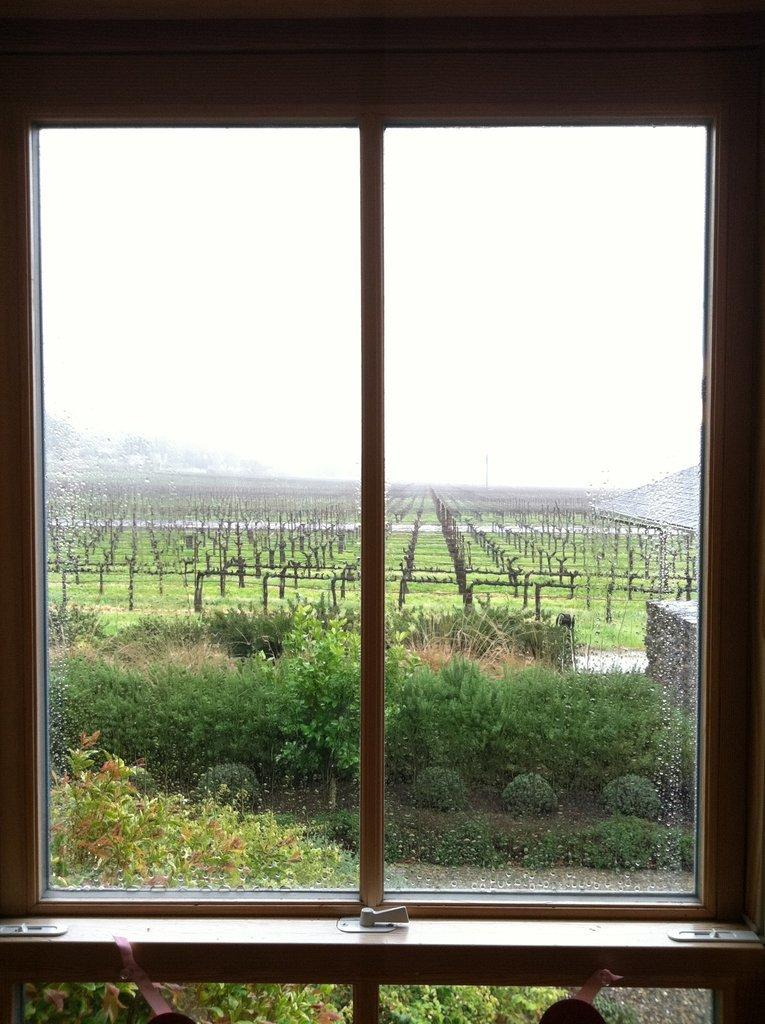What is the main object visible in the image? There is a door in the image. What can be seen through the door? Trees are visible through the door. What is located behind the trees? There is a farm behind the trees. What is present on the farm? The farm contains trees. Where is the building located in the image? The building is on the left side of the image. What type of lift is present in the image? There is no lift present in the image; it features a door, trees, a farm, and a building. What tool is being used to hammer nails in the image? There is no hammer or nails present in the image. 